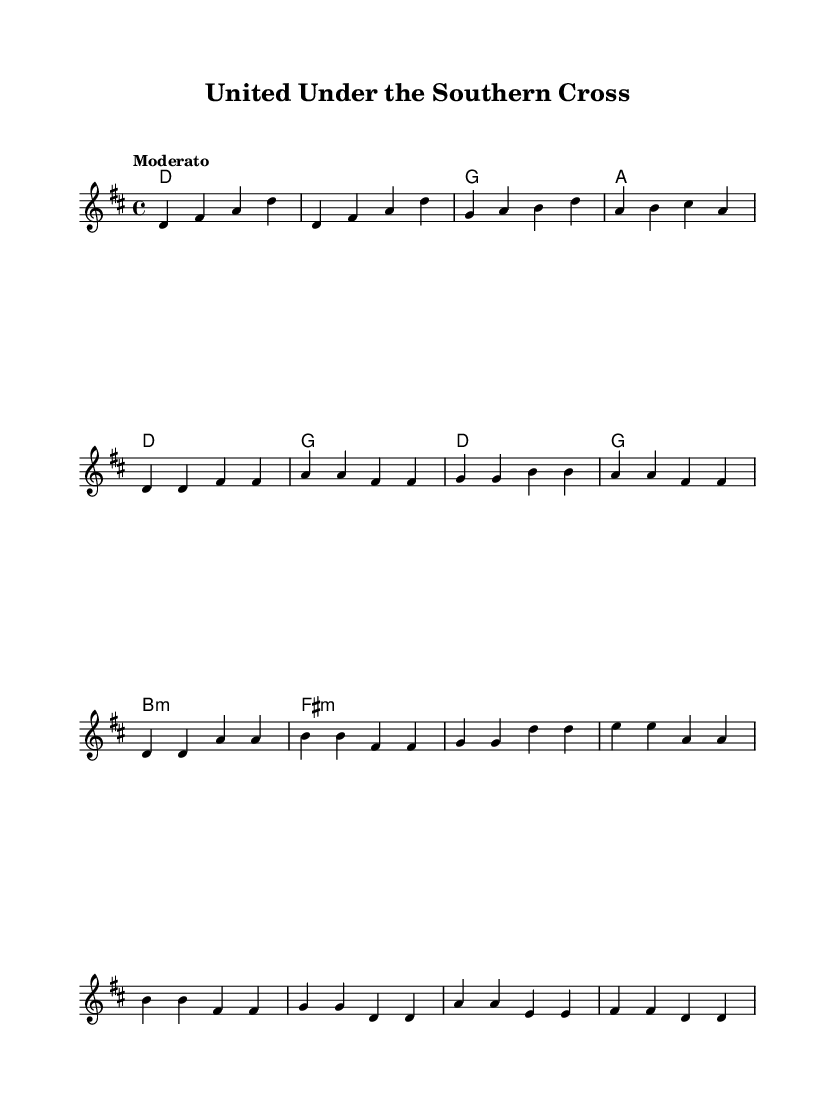What is the key signature of this music? The key signature is indicated at the beginning and shows two sharps, F sharp and C sharp. This indicates the piece is in D major.
Answer: D major What is the time signature of this music? The time signature is shown as 4/4 at the beginning, which means there are four beats in each measure and the quarter note gets one beat.
Answer: 4/4 What is the tempo marking for this piece? The tempo marking is given as "Moderato," which indicates a moderate speed, typically around 108 to 120 beats per minute.
Answer: Moderato What is the first chord played in the intro? The first chord in the harmonies section during the intro is a D major chord, which is indicated by the letter D.
Answer: D Which section has a bridge and what is its first chord? The bridge is identified in the music structure, and its first chord is B minor, indicated by "b:min" in the harmonies.
Answer: B minor What is the highest note in the melody? The highest note in the melody section is A in the octave above, specifically in the chorus part of the score.
Answer: A What do the verses primarily feature in terms of melodic motion? The verses feature primarily stepwise motion between adjacent notes, creating a smooth melodic line without large leaps.
Answer: Stepwise motion 